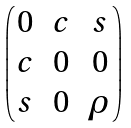<formula> <loc_0><loc_0><loc_500><loc_500>\begin{pmatrix} 0 & c & s \\ c & 0 & 0 \\ s & 0 & \rho \end{pmatrix}</formula> 